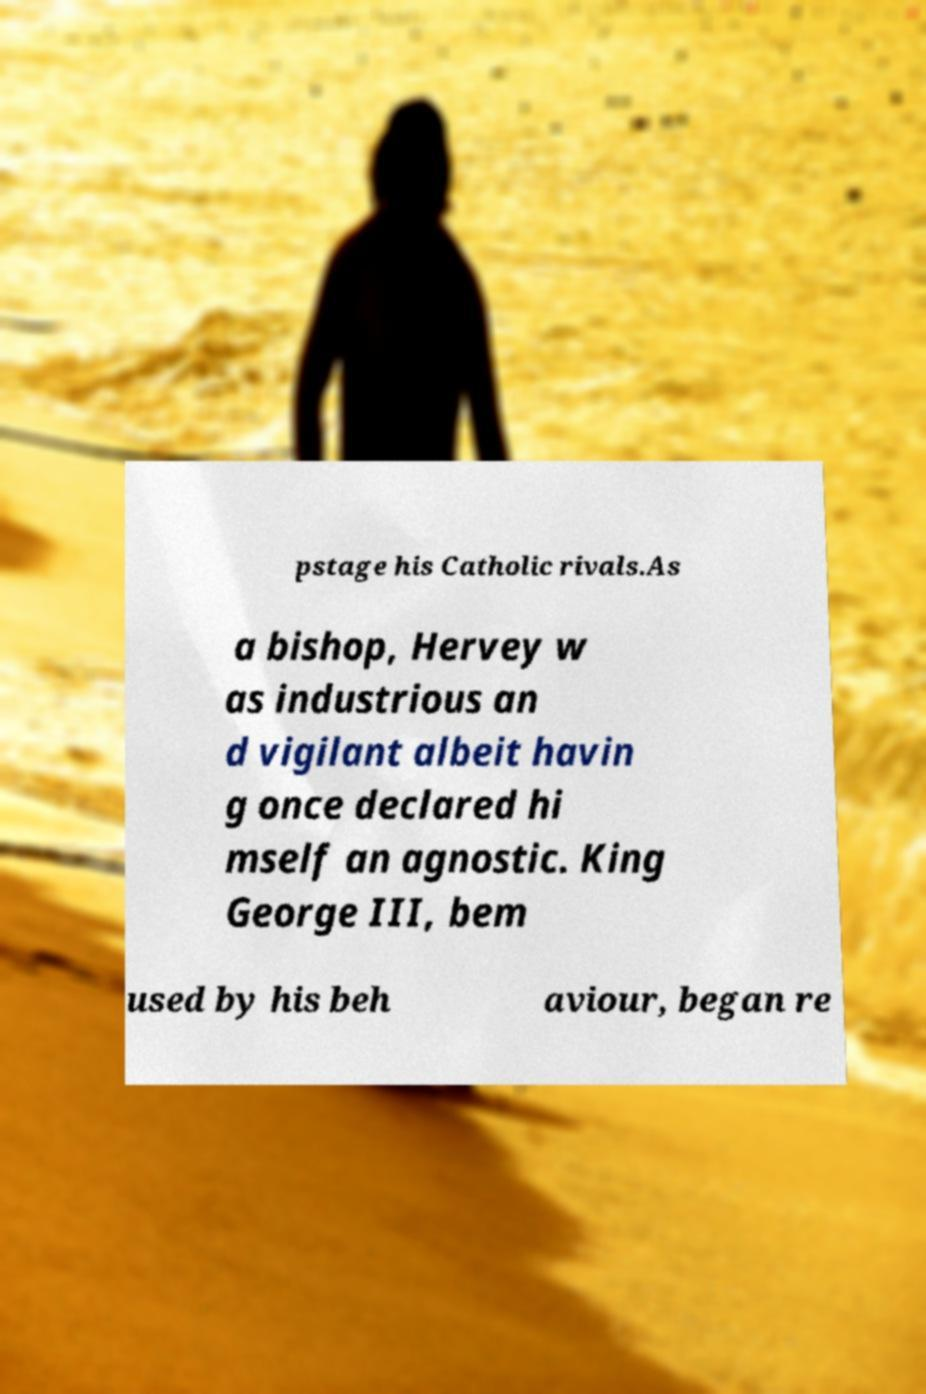There's text embedded in this image that I need extracted. Can you transcribe it verbatim? pstage his Catholic rivals.As a bishop, Hervey w as industrious an d vigilant albeit havin g once declared hi mself an agnostic. King George III, bem used by his beh aviour, began re 